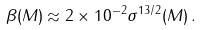<formula> <loc_0><loc_0><loc_500><loc_500>\beta ( M ) \approx 2 \times 1 0 ^ { - 2 } \sigma ^ { 1 3 / 2 } ( M ) \, .</formula> 